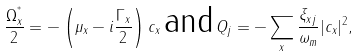Convert formula to latex. <formula><loc_0><loc_0><loc_500><loc_500>\frac { \Omega _ { x } ^ { ^ { * } } } { 2 } = - \left ( \mu _ { x } - i \frac { \Gamma _ { x } } { 2 } \right ) c _ { x } \, \text {and} \, Q _ { j } = - \sum _ { x } \frac { \xi _ { x j } } { \omega _ { m } } | c _ { x } | ^ { 2 } ,</formula> 